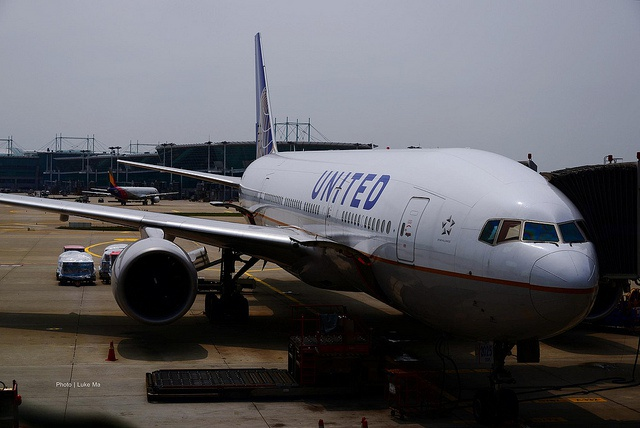Describe the objects in this image and their specific colors. I can see airplane in darkgray, black, and gray tones, truck in darkgray, black, maroon, and gray tones, truck in darkgray, black, gray, and lightgray tones, and airplane in darkgray, black, gray, and maroon tones in this image. 